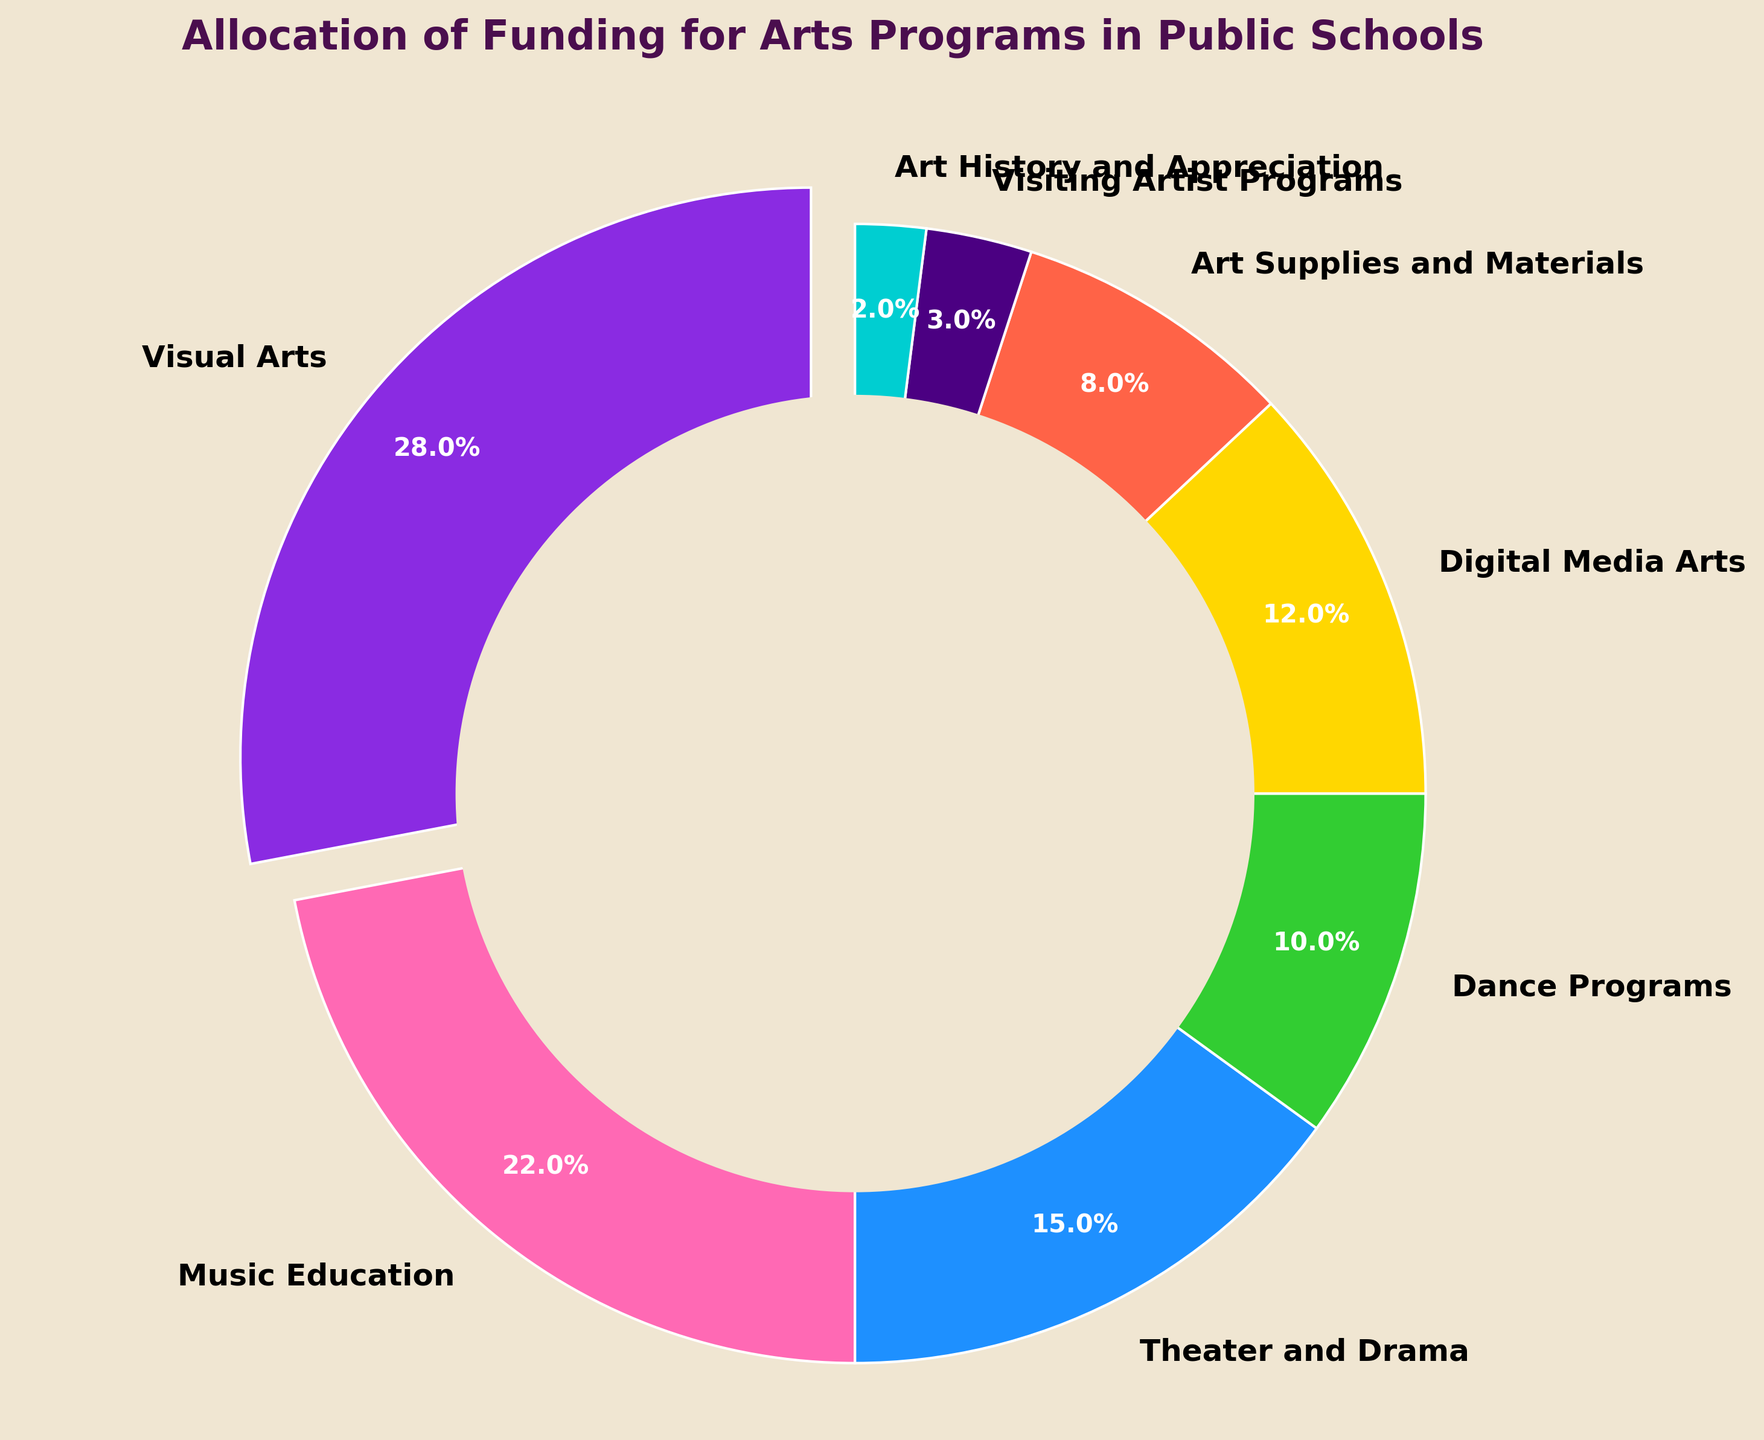Which category received the highest percentage of funding? The category with the highest percentage can be identified by looking at the largest wedge in the pie chart. The "Visual Arts" wedge is the largest and is indicated by the label showing 28%.
Answer: Visual Arts What is the combined percentage of funding for Theater and Drama and Dance Programs? Add the percentages for Theater and Drama and Dance Programs: 15% + 10% = 25%.
Answer: 25% Which category received less funding, Music Education or Digital Media Arts? Compare the wedges labeled "Music Education" and "Digital Media Arts". Music Education has 22% and Digital Media Arts has 12%.
Answer: Digital Media Arts How much more funding does Visual Arts receive compared to Art Supplies and Materials? Subtract the percentage for Art Supplies and Materials from Visual Arts: 28% - 8% = 20%.
Answer: 20% What percentage of funding is allocated to categories with less than 10% each? Add the percentages of Dance Programs, Art Supplies and Materials, Visiting Artist Programs, and Art History and Appreciation: 10% + 8% + 3% + 2% = 23%.
Answer: 23% Which category has the smallest slice in the pie chart? The smallest wedge in the pie chart represents the category receiving the least funding. The "Art History and Appreciation" wedge is the smallest and shows 2%.
Answer: Art History and Appreciation How does the funding for Digital Media Arts compare to that of Dance Programs? Compare the wedges labeled "Digital Media Arts" and "Dance Programs". Digital Media Arts, with 12%, receives more funding than Dance Programs, which has 10%.
Answer: Digital Media Arts receives more What is the total percentage of funding allocated to performing arts programs (Music Education, Theater and Drama, and Dance Programs)? Add the percentages for Music Education, Theater and Drama, and Dance Programs: 22% + 15% + 10% = 47%.
Answer: 47% What color represents the category with 22% funding? Identify the color of the wedge labeled "Music Education" which is at 22%. The corresponding color to this wedge is pink.
Answer: Pink What is the difference in funding between the highest and lowest funded categories? Subtract the percentage of the lowest funded category (Art History and Appreciation, 2%) from the highest funded category (Visual Arts, 28%): 28% - 2% = 26%.
Answer: 26% 